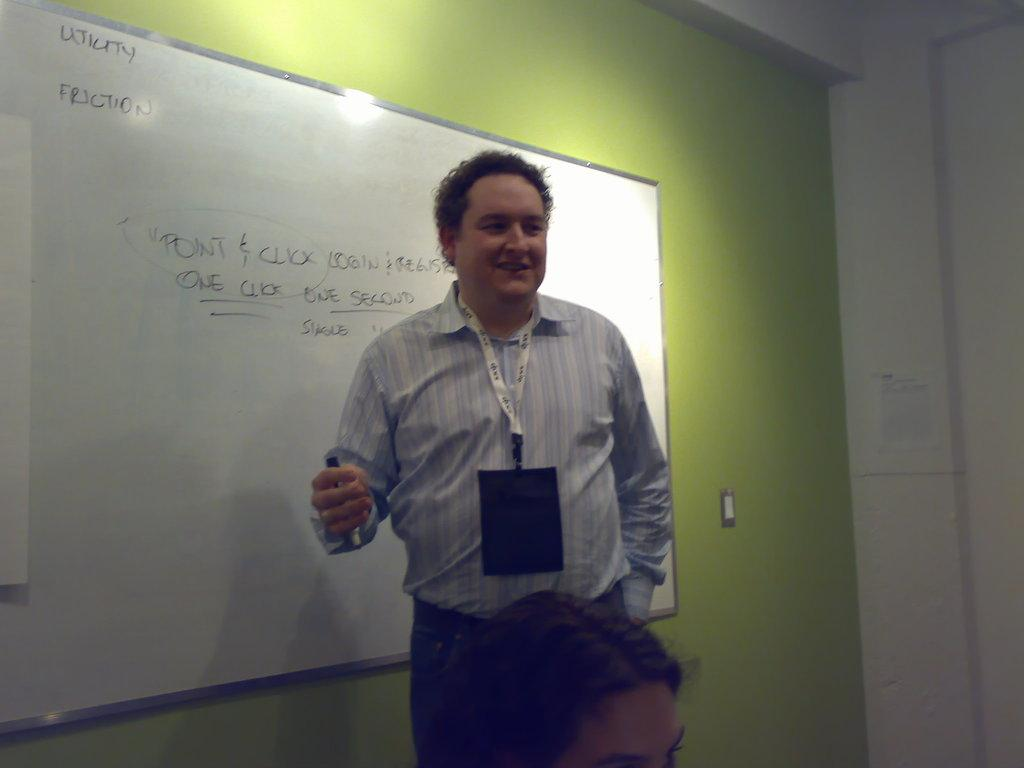<image>
Relay a brief, clear account of the picture shown. A man stands in front of a white board with the word, "Utility" written in the corner. 